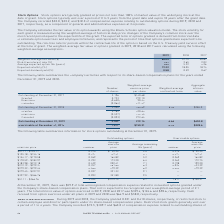According to Roper Technologies's financial document, How are stock options typically granted? at prices not less than 100% of market value of the underlying stock at the date of grant. The document states: "ock Options — Stock options are typically granted at prices not less than 100% of market value of the underlying stock at the date of grant. Stock opt..." Also, What were the compensation expenses relating to outstanding options as a component of general and administrative expenses during 2018 and 2019, respectively? The document shows two values: $23.2 and $32.0. From the document: "after the grant date. The Company recorded $32.0, $23.2, and $18.3 of compensation expense relating to outstanding options during 2019, 2018 and 2017,..." Also, What was the weighted-average fair value of options granted in 2017, 2018, and 2019, respectively? The document contains multiple relevant values: 40.87, 57.75, 68.05. From the document: "Weighted-average fair value ($) 68.05 57.75 40.87 Weighted-average fair value ($) 68.05 57.75 40.87 Weighted-average fair value ($) 68.05 57.75 40.87..." Also, can you calculate: What is the percentage change in the weighted-average fair value of options granted in 2019 compared to 2017? To answer this question, I need to perform calculations using the financial data. The calculation is: (68.05-40.87)/40.87 , which equals 66.5 (percentage). This is based on the information: "Weighted-average fair value ($) 68.05 57.75 40.87 Weighted-average fair value ($) 68.05 57.75 40.87..." The key data points involved are: 40.87, 68.05. Additionally, Which year had the highest expected dividend yield? According to the financial document, 2017. The relevant text states: "2019 2018 2017..." Also, can you calculate: What is the average weighted-average fair value of options granted from 2017 to 2019? To answer this question, I need to perform calculations using the financial data. The calculation is: (68.05+57.75+40.87)/3 , which equals 55.56. This is based on the information: "Weighted-average fair value ($) 68.05 57.75 40.87 Weighted-average fair value ($) 68.05 57.75 40.87 Weighted-average fair value ($) 68.05 57.75 40.87..." The key data points involved are: 40.87, 57.75, 68.05. 